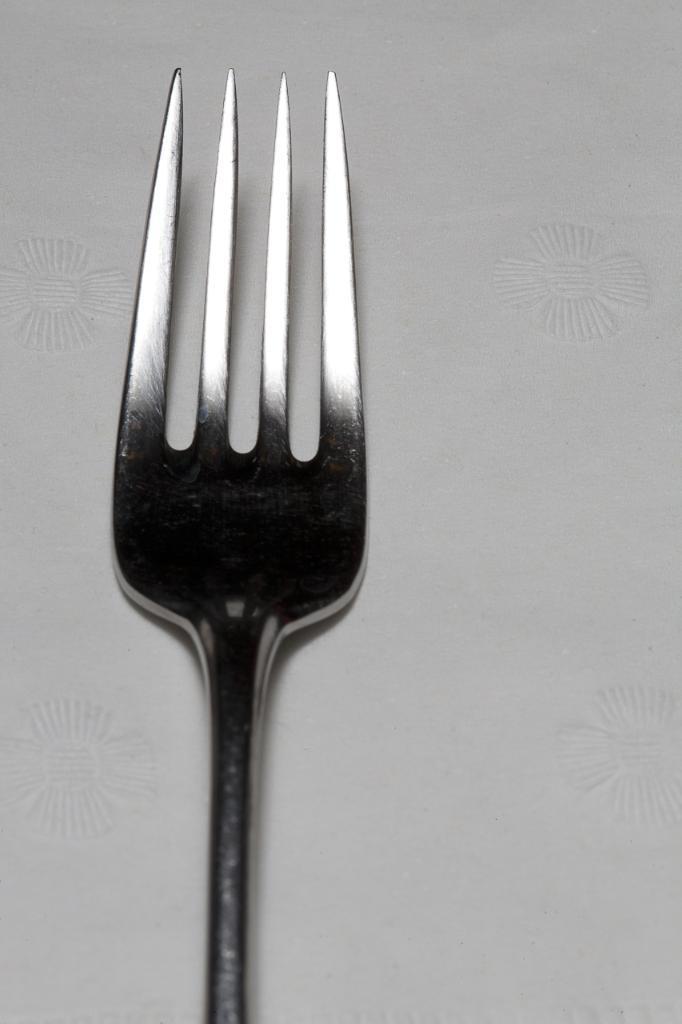Describe this image in one or two sentences. In this image I can see a fork on a surface. 